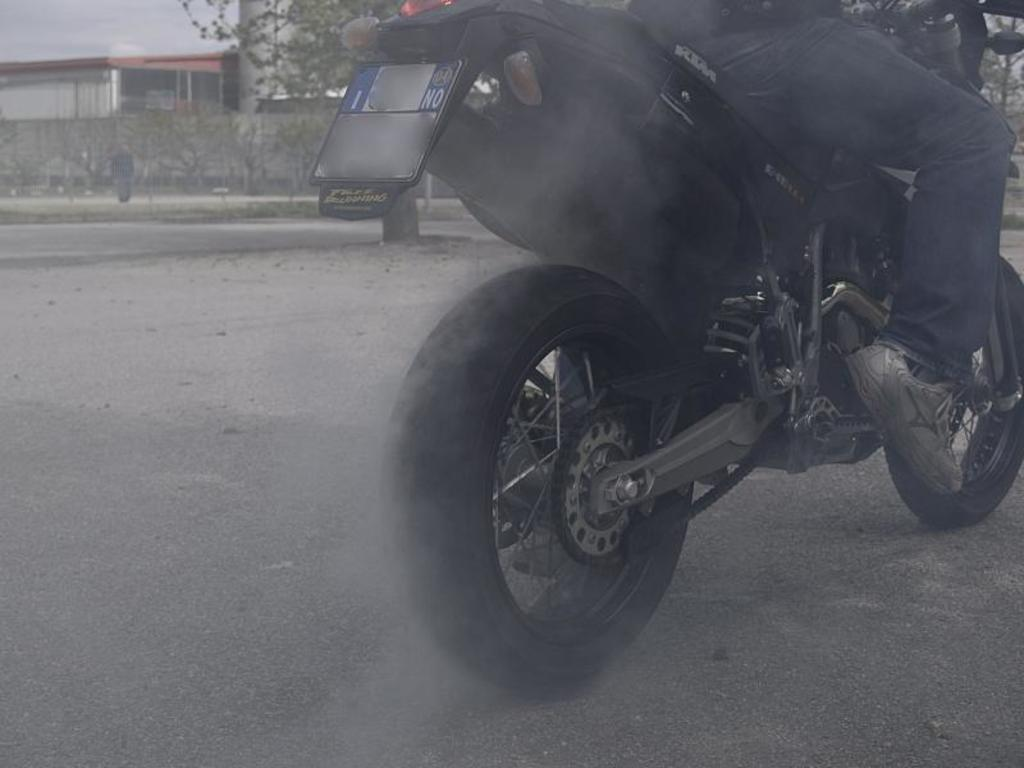What is the person in the image doing? There is a person sitting on a bike in the image. What can be seen in the background of the image? There is a building, trees, and a wall in the background of the image. What type of yam is being used to set a new record in the image? There is no yam or record-setting activity present in the image. How does the person's hair look in the image? The provided facts do not mention the person's hair, so we cannot determine its appearance from the image. 